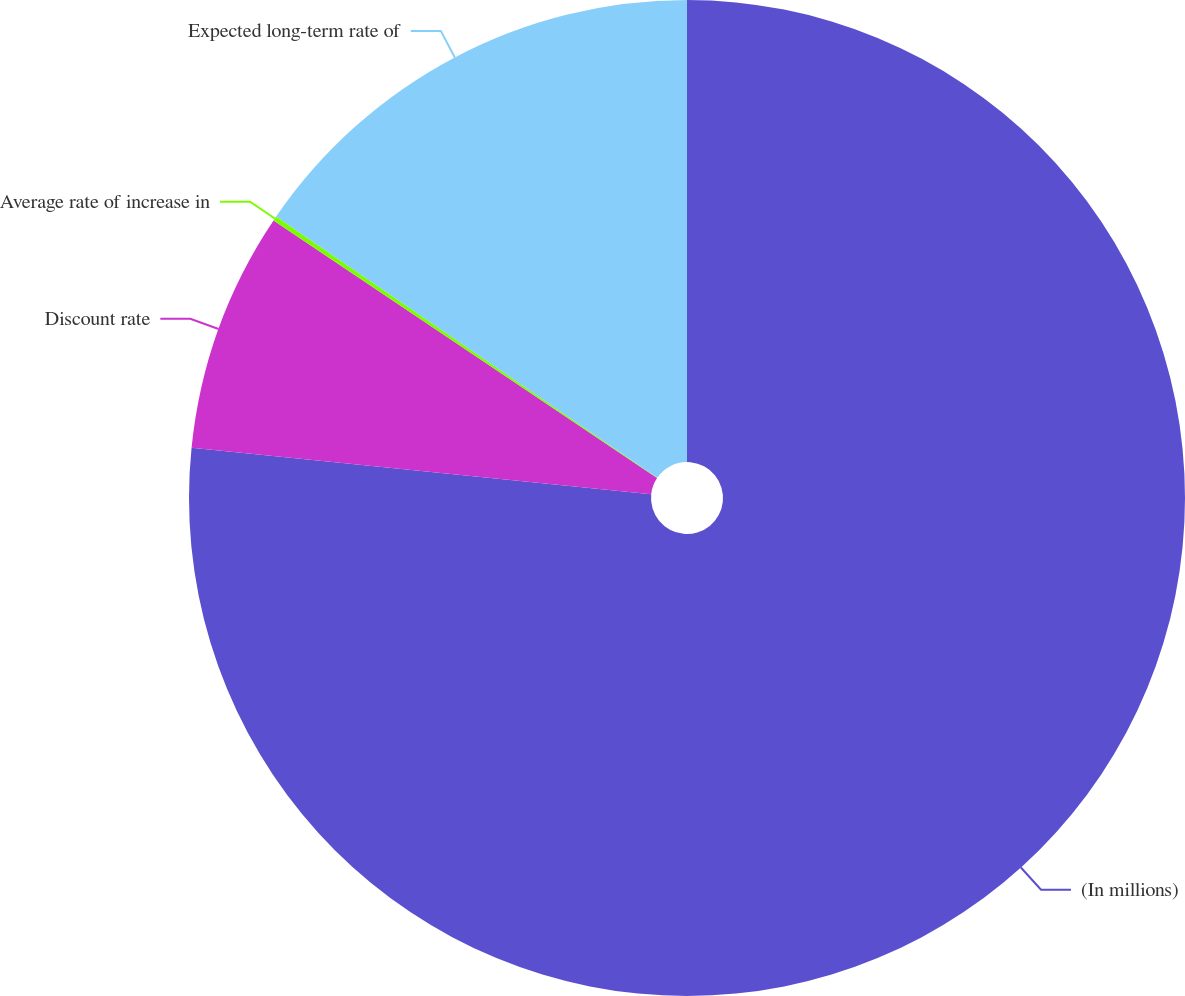<chart> <loc_0><loc_0><loc_500><loc_500><pie_chart><fcel>(In millions)<fcel>Discount rate<fcel>Average rate of increase in<fcel>Expected long-term rate of<nl><fcel>76.61%<fcel>7.8%<fcel>0.15%<fcel>15.44%<nl></chart> 